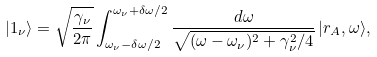Convert formula to latex. <formula><loc_0><loc_0><loc_500><loc_500>| 1 _ { \nu } \rangle = \sqrt { \frac { \gamma _ { \nu } } { 2 \pi } } \int _ { \omega _ { \nu } - \delta \omega / 2 } ^ { \omega _ { \nu } + \delta \omega / 2 } \frac { d \omega } { \sqrt { ( \omega - \omega _ { \nu } ) ^ { 2 } + \gamma _ { \nu } ^ { 2 } / 4 } } \, | r _ { A } , \omega \rangle ,</formula> 